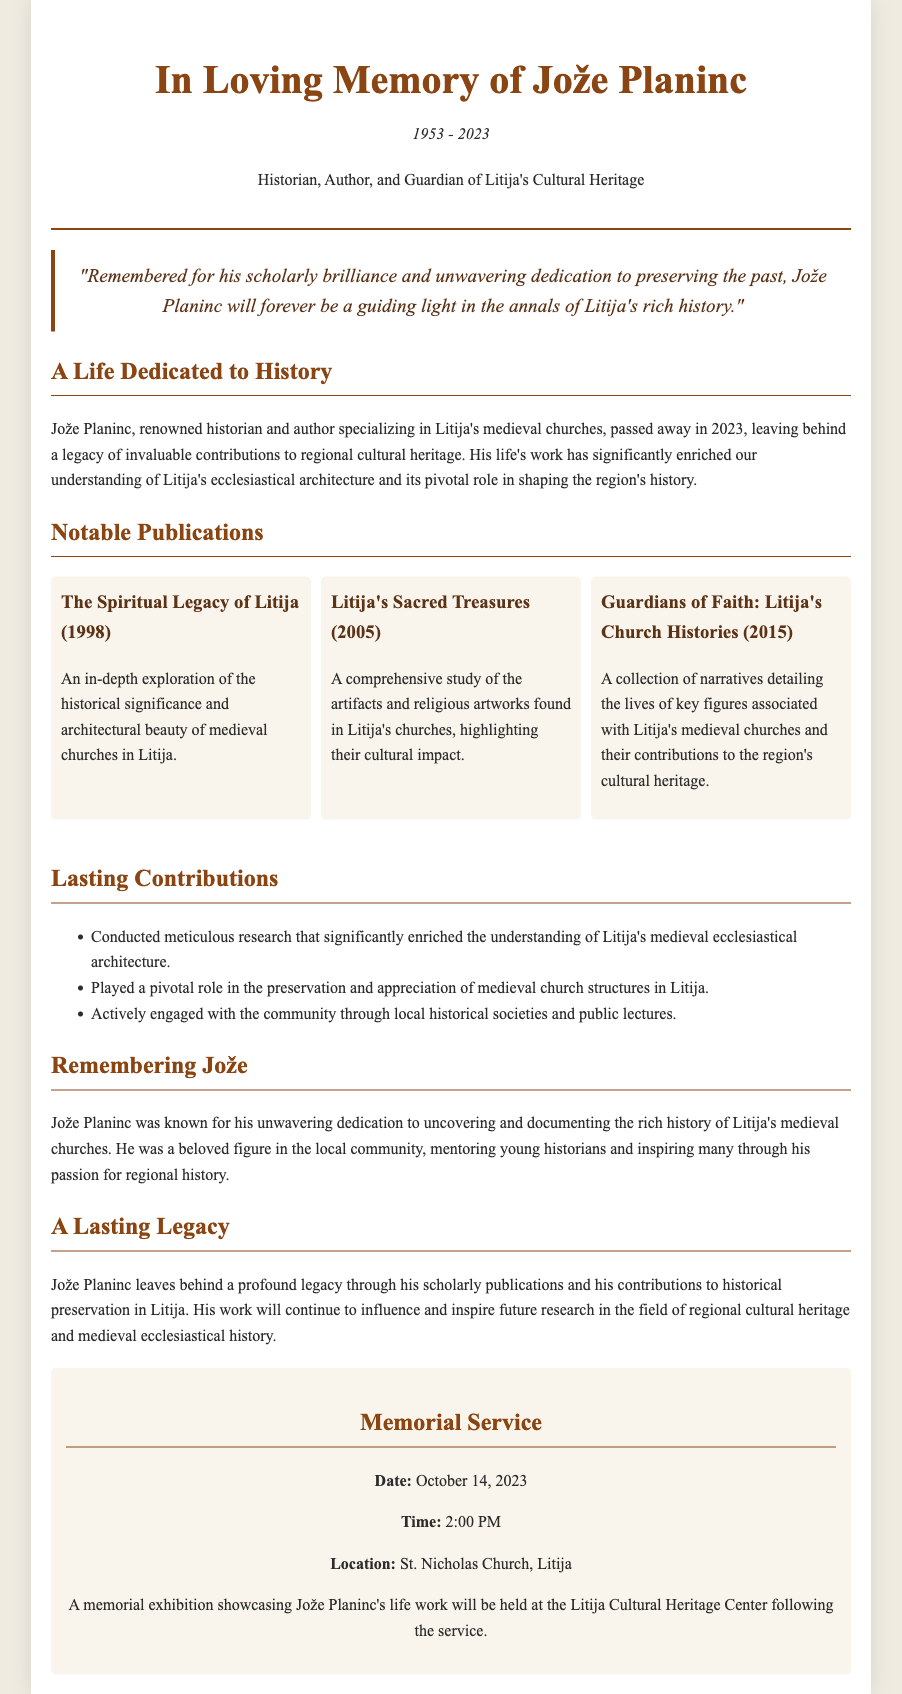What were Jože Planinc's years of birth and death? The document mentions that Jože Planinc was born in 1953 and passed away in 2023.
Answer: 1953 - 2023 What is the title of Jože Planinc's 1998 publication? The document specifies the title of the publication from 1998 as "The Spiritual Legacy of Litija."
Answer: The Spiritual Legacy of Litija Which church is mentioned in the memorial service location? The memorial service is set to take place at St. Nicholas Church, as stated in the document.
Answer: St. Nicholas Church What was Jože Planinc's primary area of expertise? The document indicates that Jože Planinc specialized in Litija's medieval churches.
Answer: Medieval churches What type of event will be held following the memorial service? The document states that a memorial exhibition will be showcased at the Litija Cultural Heritage Center.
Answer: Memorial exhibition What role did Jože Planinc play in the local community? According to the document, he actively engaged with the community through historical societies and mentoring.
Answer: Mentoring young historians What notable contribution did Planinc make to ecclesiastical architecture? The document highlights that he conducted meticulous research enriching the understanding of medieval ecclesiastical architecture.
Answer: Enriched understanding What concept does the quote emphasize about Jože Planinc? The quote focuses on his scholarly brilliance and dedication to preserving history, emphasizing his lasting impact.
Answer: Guiding light in history 